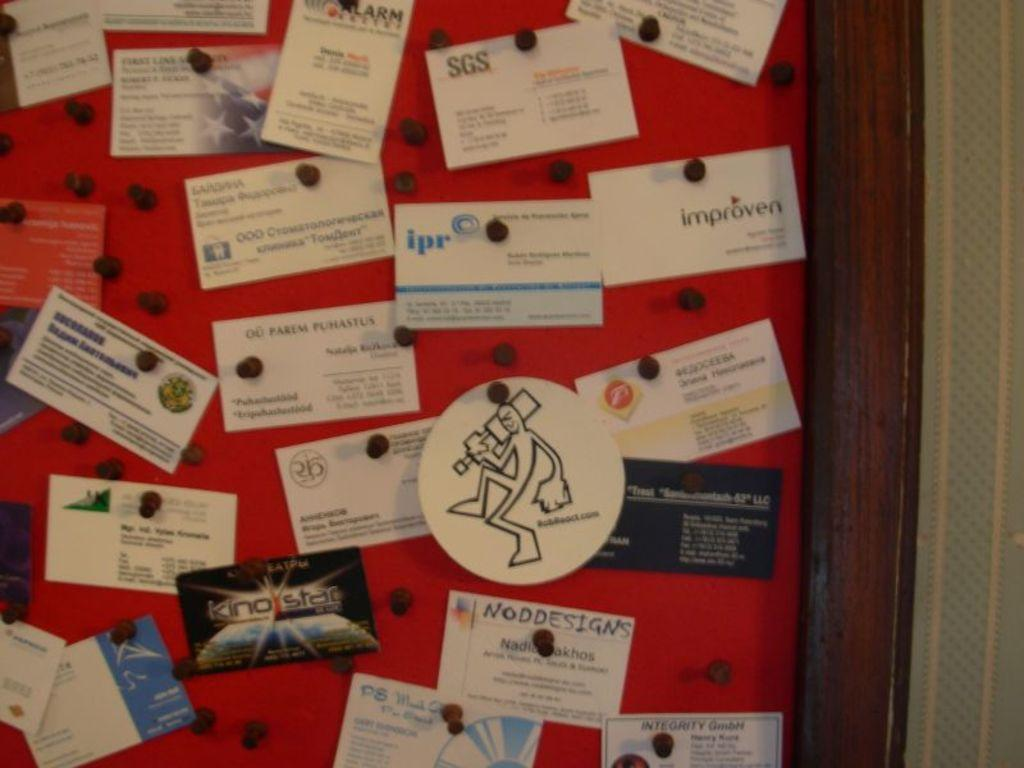<image>
Provide a brief description of the given image. Board with tiny business cards and one that says "NODDESIGNS". 